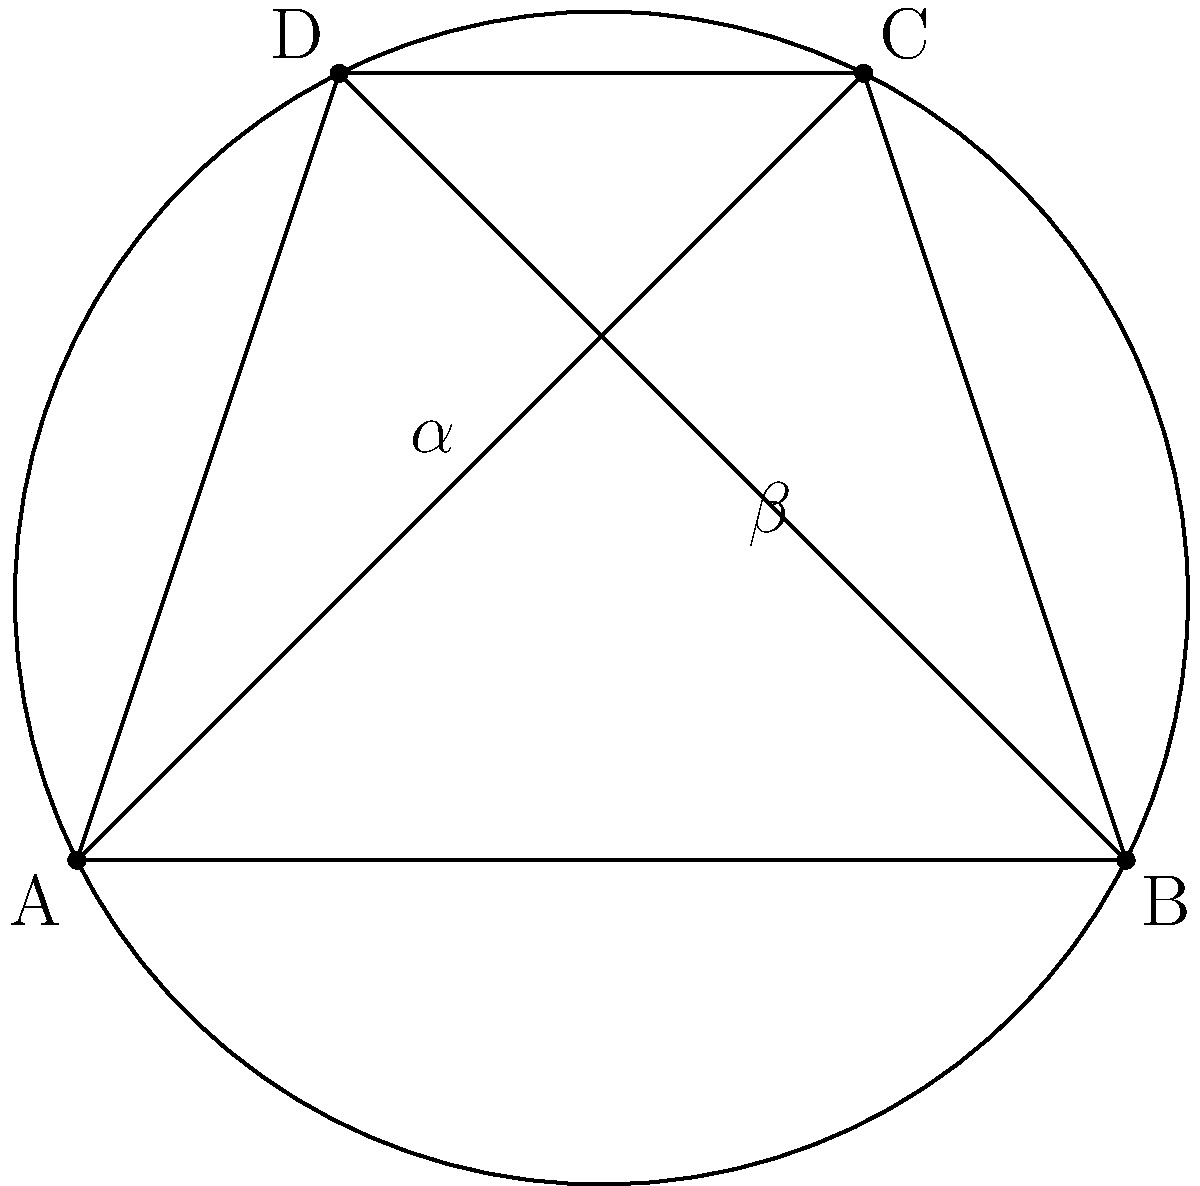In the cyclic quadrilateral ABCD, AC and BD are the diagonals intersecting at point E. If $\angle AEB = \alpha$ and $\angle BED = \beta$, prove that $\alpha + \beta = 180°$. How might this property relate to the concept of complementary angles in quantum mechanics, which is often used in describing the spin states of particles like those hypothesized in dark matter theories? Let's approach this step-by-step:

1) In a cyclic quadrilateral, opposite angles are supplementary. This means:
   $\angle BAD + \angle BCD = 180°$
   $\angle ABC + \angle ADC = 180°$

2) The inscribed angle theorem states that an angle inscribed in a circle is half the central angle subtending the same arc. Therefore:
   $\angle BAD = \frac{1}{2}\angle BCD$
   $\angle ABC = \frac{1}{2}\angle ADC$

3) Now, let's focus on the diagonals AC and BD. They form four triangles: AEB, BEC, CED, and DEA.

4) In triangle AEB:
   $\angle BAE + \angle ABE + \alpha = 180°$ (sum of angles in a triangle)

5) In triangle BED:
   $\angle ABE + \angle BDE + \beta = 180°$

6) Adding these equations:
   $\angle BAE + \angle ABE + \alpha + \angle ABE + \angle BDE + \beta = 360°$
   $\angle BAE + 2\angle ABE + \angle BDE + \alpha + \beta = 360°$

7) But $\angle BAE + \angle ABE + \angle BDE = 180°$ (they form a straight line)

8) Substituting this in the equation from step 6:
   $180° + \angle ABE + \alpha + \beta = 360°$
   $\angle ABE + \alpha + \beta = 180°$

9) Since $\angle ABE$ is an inscribed angle, it's half of the central angle. The other half is made up by $\alpha + \beta$.

Therefore, $\alpha + \beta = 180°$.

Relating to quantum mechanics and dark matter:
This property of complementary angles in cyclic quadrilaterals ($\alpha + \beta = 180°$) is analogous to the concept of complementary observables in quantum mechanics, such as position and momentum, or different components of spin. In the context of dark matter theories, this could be relevant when considering the quantum properties of hypothetical dark matter particles, where complementary observables might play a role in describing their behavior or interactions.
Answer: $\alpha + \beta = 180°$ 